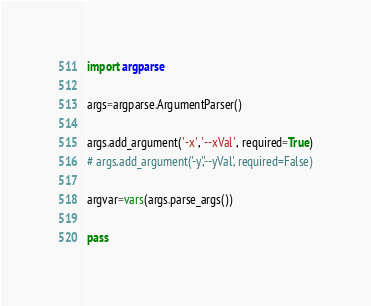Convert code to text. <code><loc_0><loc_0><loc_500><loc_500><_Python_>import argparse

args=argparse.ArgumentParser()

args.add_argument('-x','--xVal', required=True)
# args.add_argument('-y','--yVal', required=False)

argvar=vars(args.parse_args())

pass

</code> 